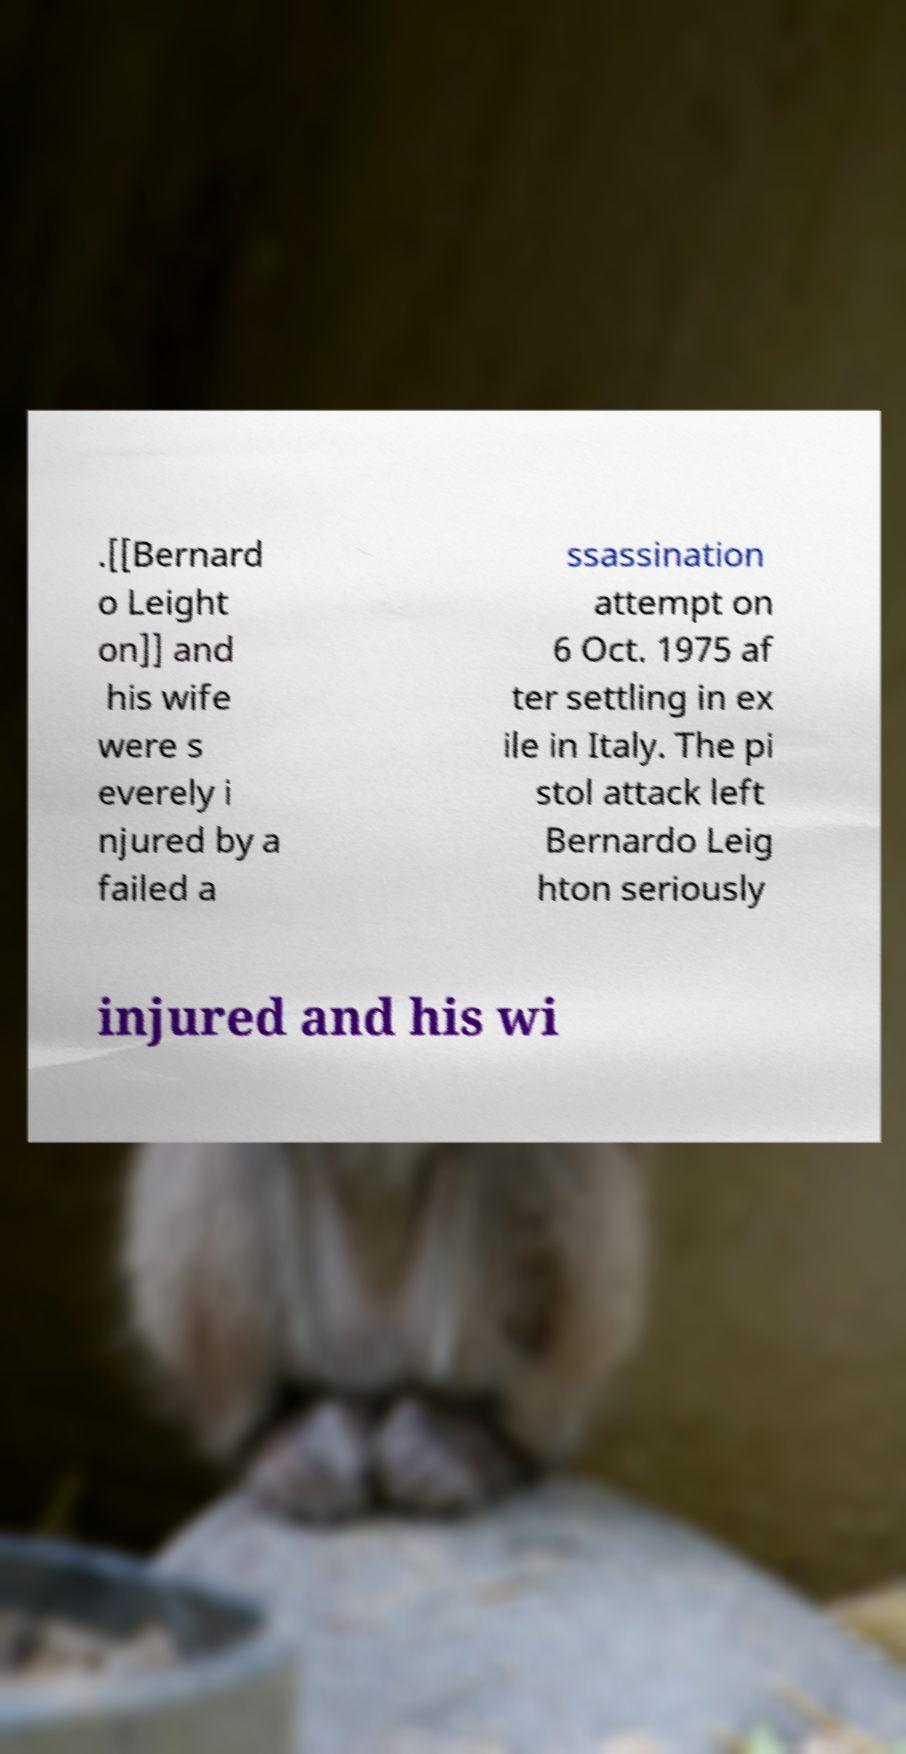For documentation purposes, I need the text within this image transcribed. Could you provide that? .[[Bernard o Leight on]] and his wife were s everely i njured by a failed a ssassination attempt on 6 Oct. 1975 af ter settling in ex ile in Italy. The pi stol attack left Bernardo Leig hton seriously injured and his wi 